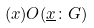Convert formula to latex. <formula><loc_0><loc_0><loc_500><loc_500>( x ) O ( \underline { x } \colon G )</formula> 